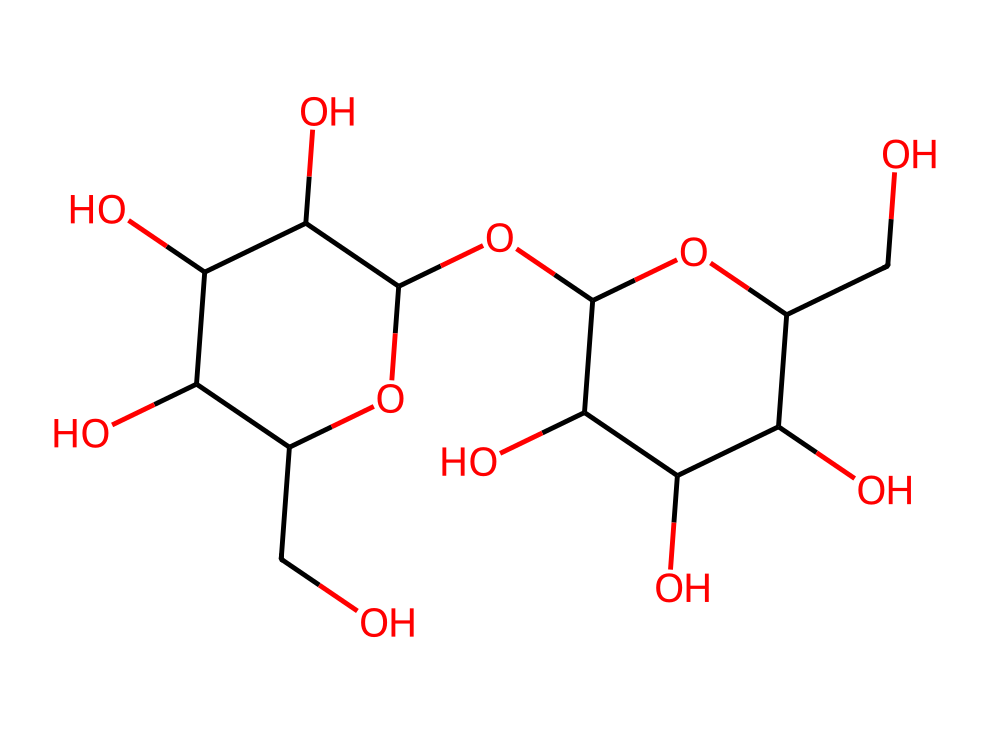What is the main function of glycogen in canine muscle tissue? Glycogen serves as the primary storage form of glucose in animals, providing energy during vigorous physical activity by releasing glucose molecules when needed.
Answer: energy storage How many carbon atoms are present in this glycogen structure? By analyzing the SMILES representation, we can identify each carbon atom. In this case, the structure reveals a total of 24 carbon atoms.
Answer: 24 What is the characteristic functional group in glycogen? The presence of multiple hydroxyl (-OH) groups indicates that glycogen is a carbohydrate with hydrophilic properties, essential for its solubility and interaction with water.
Answer: hydroxyl group How many oxygen atoms are found in the structure of glycogen? Counting the oxygen atoms in the provided SMILES representation indicates that there are 10 oxygen atoms in total within the glycogen structure.
Answer: 10 What type of carbohydrate is glycogen classified as? Glycogen is classified as a polysaccharide due to its structure, which consists of long chains of glucose monomers linked together in a branched form.
Answer: polysaccharide What are the key structural features that differentiate glycogen from starch? Glycogen is more highly branched compared to starch, with multiple branching points that allow for quicker mobilization of glucose when energy is needed.
Answer: highly branched How does the structural complexity of glycogen benefit canine muscle tissue? The branched structure allows for rapid access to glucose during muscular exertion, providing an efficient source of energy when the dog is active.
Answer: rapid energy access 